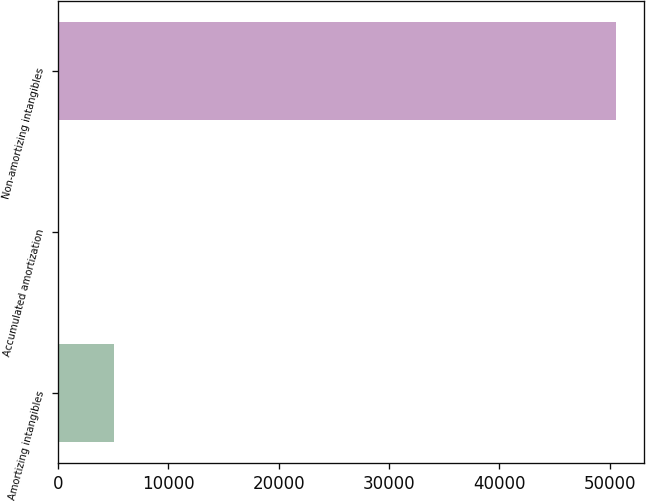<chart> <loc_0><loc_0><loc_500><loc_500><bar_chart><fcel>Amortizing intangibles<fcel>Accumulated amortization<fcel>Non-amortizing intangibles<nl><fcel>5101.5<fcel>50<fcel>50565<nl></chart> 